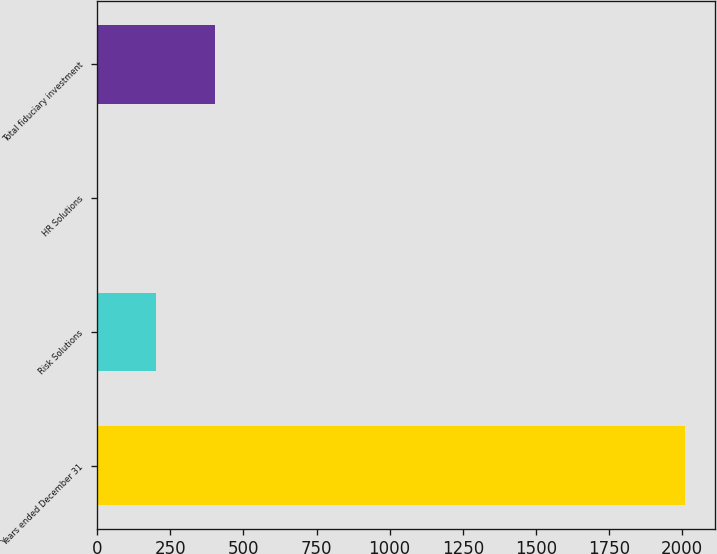<chart> <loc_0><loc_0><loc_500><loc_500><bar_chart><fcel>Years ended December 31<fcel>Risk Solutions<fcel>HR Solutions<fcel>Total fiduciary investment<nl><fcel>2010<fcel>201.9<fcel>1<fcel>402.8<nl></chart> 